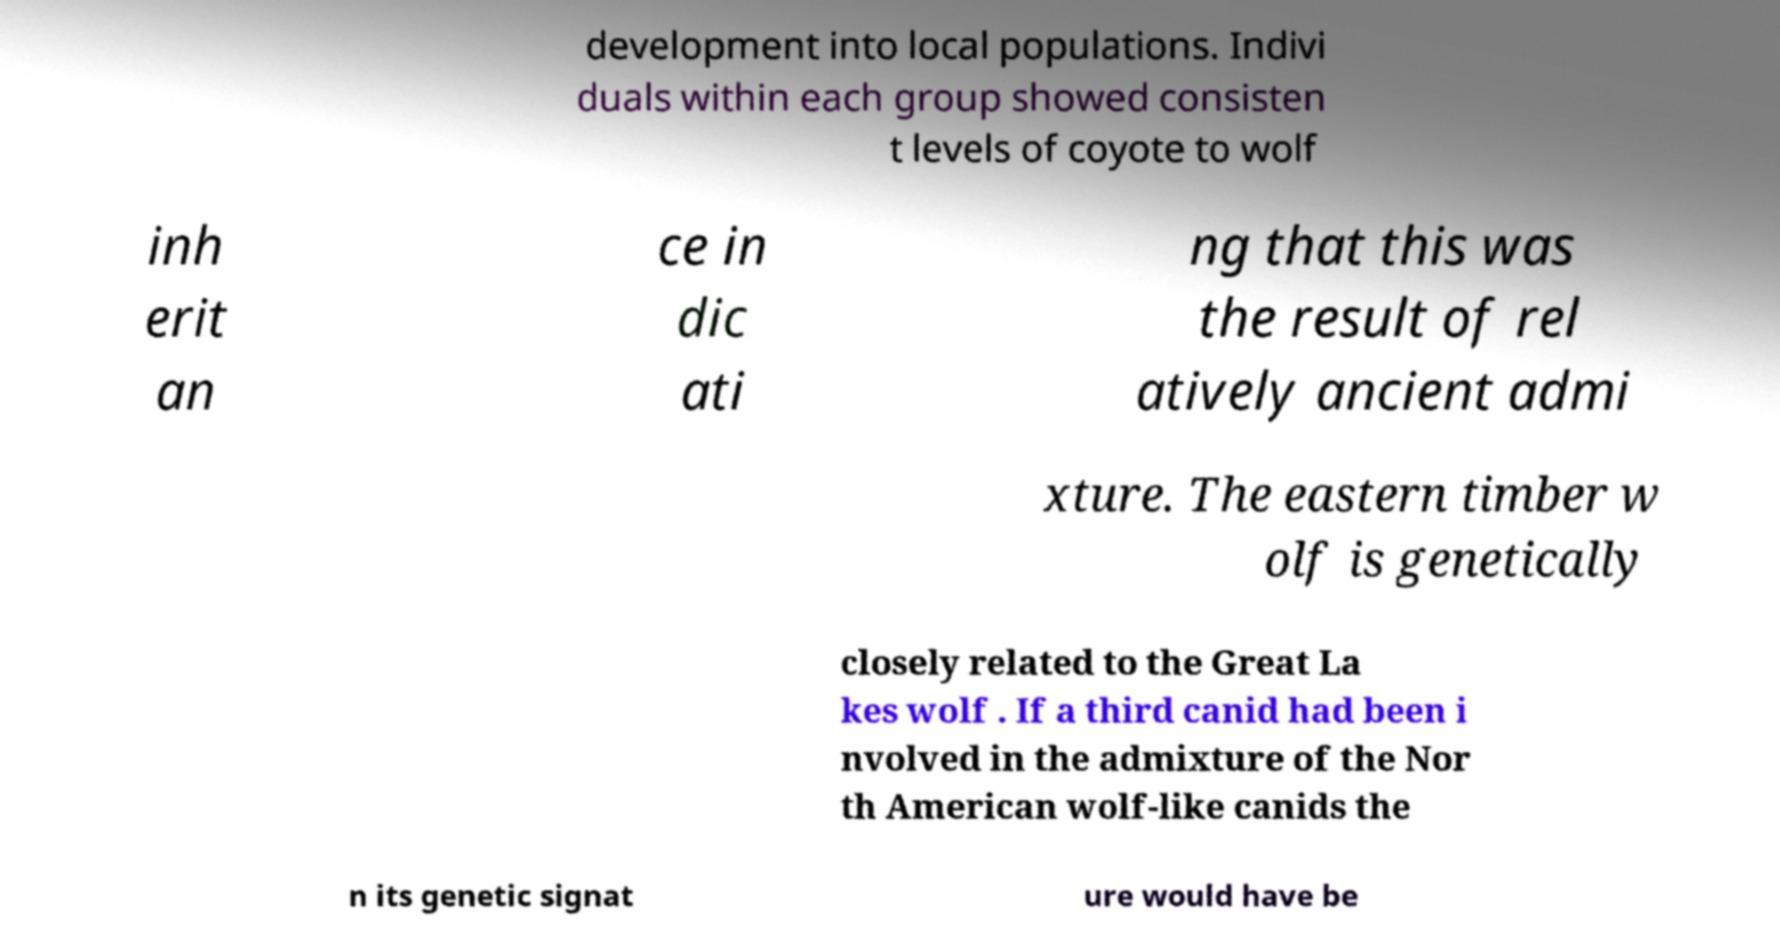Please identify and transcribe the text found in this image. development into local populations. Indivi duals within each group showed consisten t levels of coyote to wolf inh erit an ce in dic ati ng that this was the result of rel atively ancient admi xture. The eastern timber w olf is genetically closely related to the Great La kes wolf . If a third canid had been i nvolved in the admixture of the Nor th American wolf-like canids the n its genetic signat ure would have be 